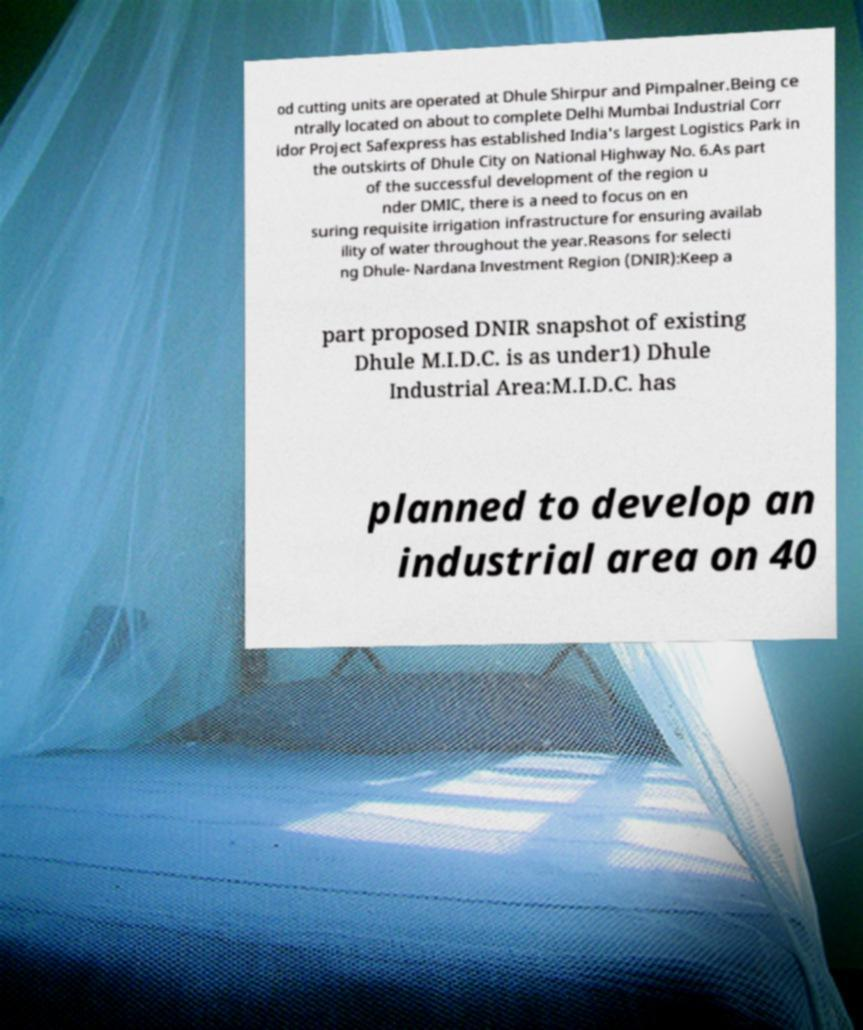Can you accurately transcribe the text from the provided image for me? od cutting units are operated at Dhule Shirpur and Pimpalner.Being ce ntrally located on about to complete Delhi Mumbai Industrial Corr idor Project Safexpress has established India's largest Logistics Park in the outskirts of Dhule City on National Highway No. 6.As part of the successful development of the region u nder DMIC, there is a need to focus on en suring requisite irrigation infrastructure for ensuring availab ility of water throughout the year.Reasons for selecti ng Dhule- Nardana Investment Region (DNIR):Keep a part proposed DNIR snapshot of existing Dhule M.I.D.C. is as under1) Dhule Industrial Area:M.I.D.C. has planned to develop an industrial area on 40 